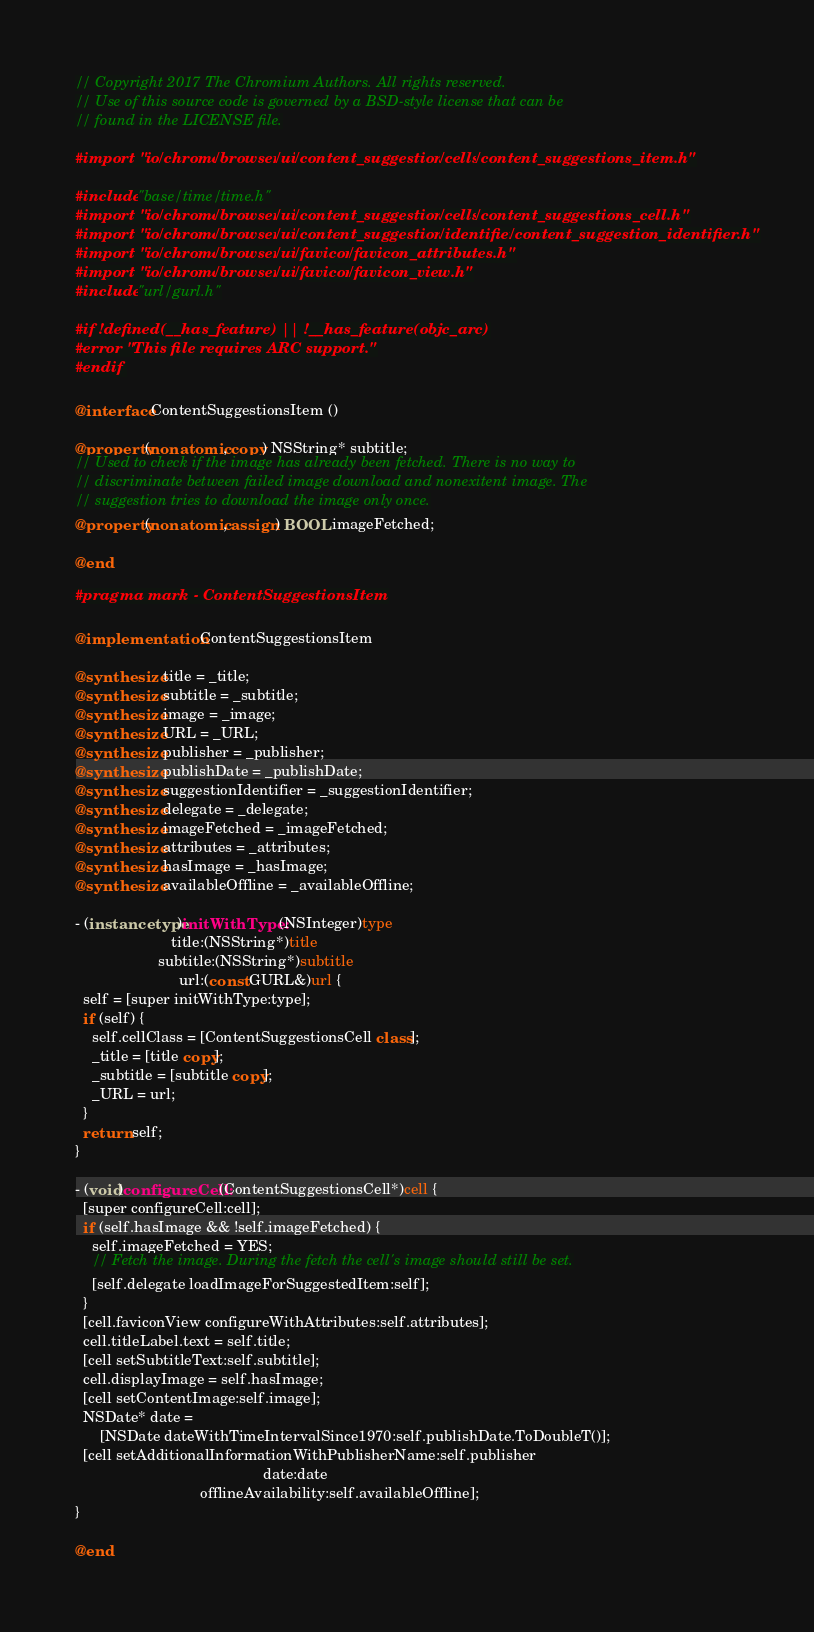Convert code to text. <code><loc_0><loc_0><loc_500><loc_500><_ObjectiveC_>// Copyright 2017 The Chromium Authors. All rights reserved.
// Use of this source code is governed by a BSD-style license that can be
// found in the LICENSE file.

#import "ios/chrome/browser/ui/content_suggestions/cells/content_suggestions_item.h"

#include "base/time/time.h"
#import "ios/chrome/browser/ui/content_suggestions/cells/content_suggestions_cell.h"
#import "ios/chrome/browser/ui/content_suggestions/identifier/content_suggestion_identifier.h"
#import "ios/chrome/browser/ui/favicon/favicon_attributes.h"
#import "ios/chrome/browser/ui/favicon/favicon_view.h"
#include "url/gurl.h"

#if !defined(__has_feature) || !__has_feature(objc_arc)
#error "This file requires ARC support."
#endif

@interface ContentSuggestionsItem ()

@property(nonatomic, copy) NSString* subtitle;
// Used to check if the image has already been fetched. There is no way to
// discriminate between failed image download and nonexitent image. The
// suggestion tries to download the image only once.
@property(nonatomic, assign) BOOL imageFetched;

@end

#pragma mark - ContentSuggestionsItem

@implementation ContentSuggestionsItem

@synthesize title = _title;
@synthesize subtitle = _subtitle;
@synthesize image = _image;
@synthesize URL = _URL;
@synthesize publisher = _publisher;
@synthesize publishDate = _publishDate;
@synthesize suggestionIdentifier = _suggestionIdentifier;
@synthesize delegate = _delegate;
@synthesize imageFetched = _imageFetched;
@synthesize attributes = _attributes;
@synthesize hasImage = _hasImage;
@synthesize availableOffline = _availableOffline;

- (instancetype)initWithType:(NSInteger)type
                       title:(NSString*)title
                    subtitle:(NSString*)subtitle
                         url:(const GURL&)url {
  self = [super initWithType:type];
  if (self) {
    self.cellClass = [ContentSuggestionsCell class];
    _title = [title copy];
    _subtitle = [subtitle copy];
    _URL = url;
  }
  return self;
}

- (void)configureCell:(ContentSuggestionsCell*)cell {
  [super configureCell:cell];
  if (self.hasImage && !self.imageFetched) {
    self.imageFetched = YES;
    // Fetch the image. During the fetch the cell's image should still be set.
    [self.delegate loadImageForSuggestedItem:self];
  }
  [cell.faviconView configureWithAttributes:self.attributes];
  cell.titleLabel.text = self.title;
  [cell setSubtitleText:self.subtitle];
  cell.displayImage = self.hasImage;
  [cell setContentImage:self.image];
  NSDate* date =
      [NSDate dateWithTimeIntervalSince1970:self.publishDate.ToDoubleT()];
  [cell setAdditionalInformationWithPublisherName:self.publisher
                                             date:date
                              offlineAvailability:self.availableOffline];
}

@end
</code> 